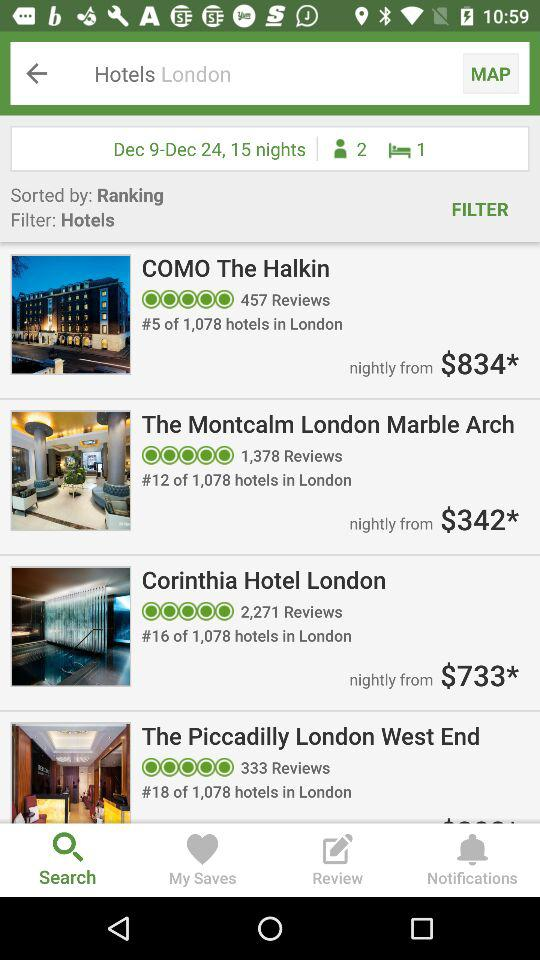How many more reviews does the Corinthia Hotel London have than the Piccadilly London West End?
Answer the question using a single word or phrase. 1938 